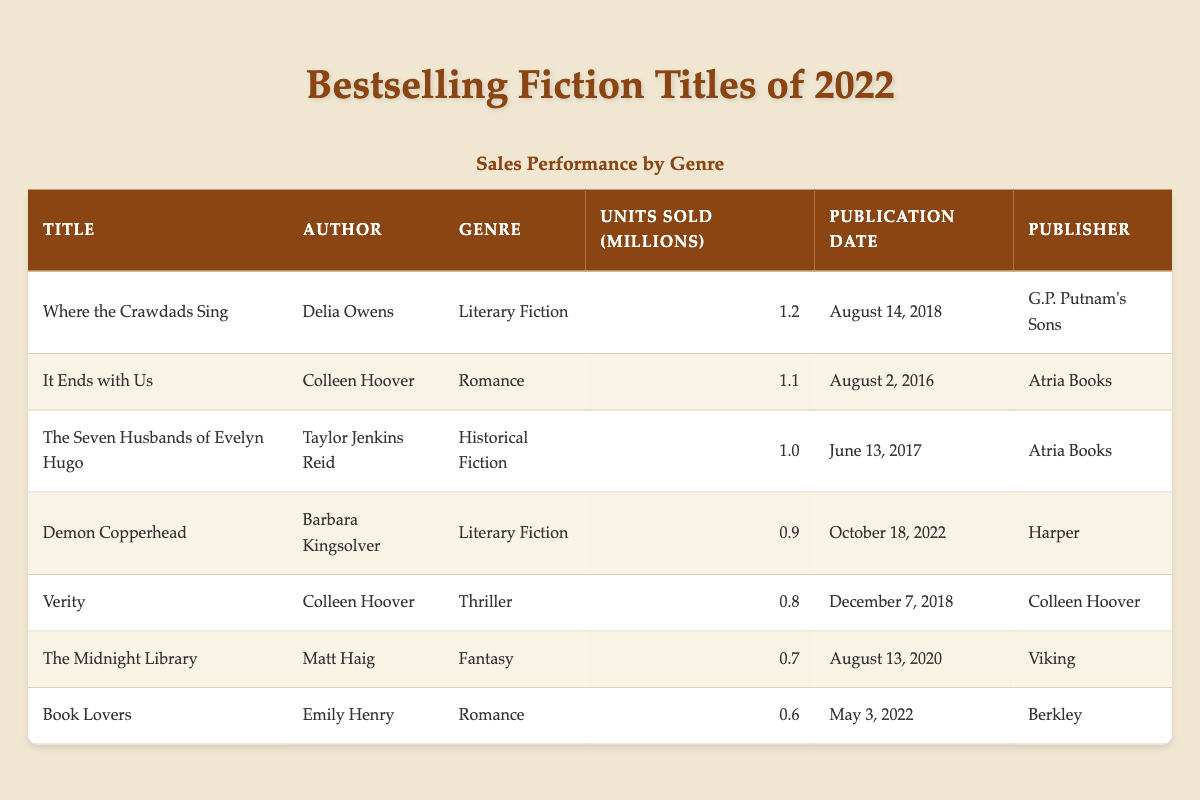What is the title of the bestselling literary fiction book in 2022? The table lists multiple books in the genre of literary fiction. The book "Where the Crawdads Sing" by Delia Owens has the highest units sold (1.2 million), making it the bestselling literary fiction title in 2022.
Answer: Where the Crawdads Sing How many units did "It Ends with Us" sell? The table shows that "It Ends with Us" by Colleen Hoover sold 1.1 million units.
Answer: 1.1 million Which genre had the lowest sales performance in the table? By reviewing the units sold for each genre, "Fantasy" (The Midnight Library) had the lowest sales at 0.7 million units compared to others.
Answer: Fantasy What is the total number of units sold for all romance titles listed? There are two romance titles: "It Ends with Us" (1.1 million) and "Book Lovers" (0.6 million). Summing these gives 1.1 + 0.6 = 1.7 million units sold for romance titles.
Answer: 1.7 million Is "Demon Copperhead" the newest book on the list? "Demon Copperhead" was published on October 18, 2022. This is the latest publication date compared to the other titles listed, confirming it is the newest book.
Answer: Yes Which author has the most entries in the bestselling list? Colleen Hoover appears twice in the list with "It Ends with Us" and "Verity". Other authors only appear once in the table.
Answer: Colleen Hoover What is the average number of units sold among all the books listed? To find the average, sum all units sold: 1.2 + 1.1 + 1.0 + 0.9 + 0.8 + 0.7 + 0.6 = 6.3 million units. Divide by the number of titles (7), giving 6.3 / 7 = approximately 0.9 million.
Answer: 0.9 million Which book was published the earliest? By examining the publication dates, "It Ends with Us" was published on August 2, 2016, which is earlier than all other titles listed.
Answer: It Ends with Us Is there any title published in 2022 that sold more than 0.6 million units? The table shows that "Demon Copperhead," published in 2022, sold 0.9 million units, which is indeed greater than 0.6 million.
Answer: Yes 